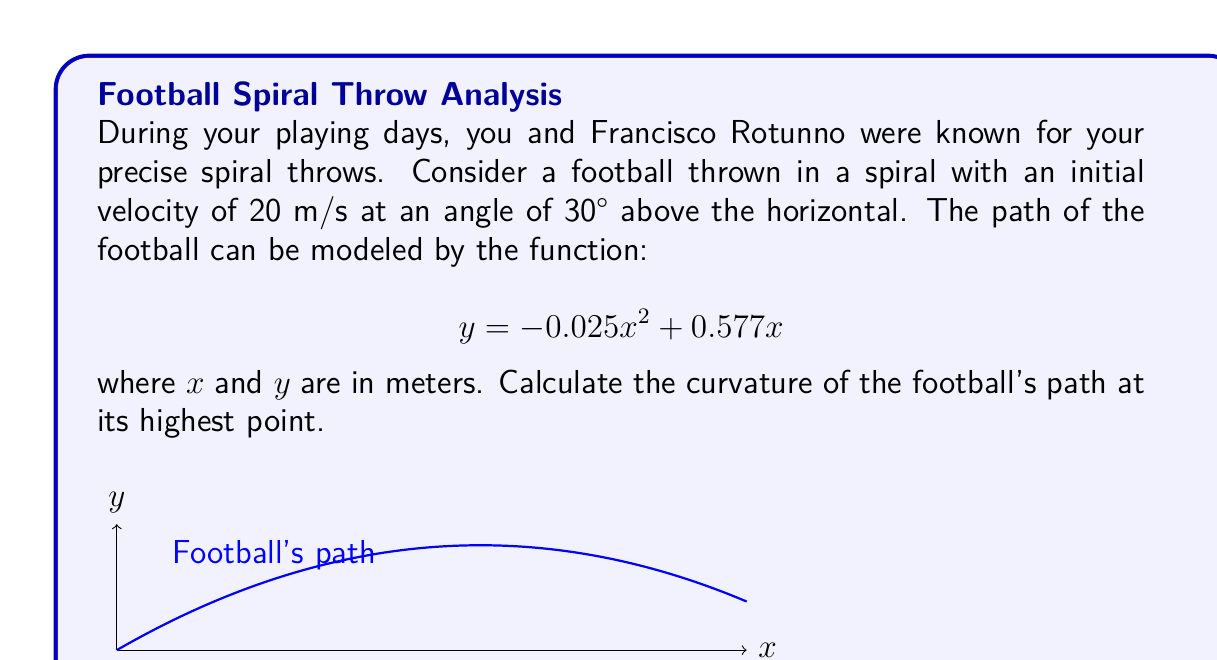Provide a solution to this math problem. Let's approach this step-by-step:

1) First, we need to find the x-coordinate of the highest point. At this point, $\frac{dy}{dx} = 0$.

2) $\frac{dy}{dx} = -0.05x + 0.577$

3) Setting this equal to zero:
   $-0.05x + 0.577 = 0$
   $-0.05x = -0.577$
   $x = 11.54$ meters

4) The curvature $\kappa$ at any point is given by:

   $$\kappa = \frac{|y''|}{(1 + (y')^2)^{3/2}}$$

5) We need to calculate $y'$ and $y''$:
   $y' = -0.05x + 0.577$
   $y'' = -0.05$

6) At $x = 11.54$:
   $y' = -0.05(11.54) + 0.577 = 0$

7) Substituting into the curvature formula:

   $$\kappa = \frac{|-0.05|}{(1 + (0)^2)^{3/2}} = 0.05$$
Answer: $0.05$ m$^{-1}$ 